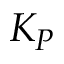<formula> <loc_0><loc_0><loc_500><loc_500>K _ { P }</formula> 